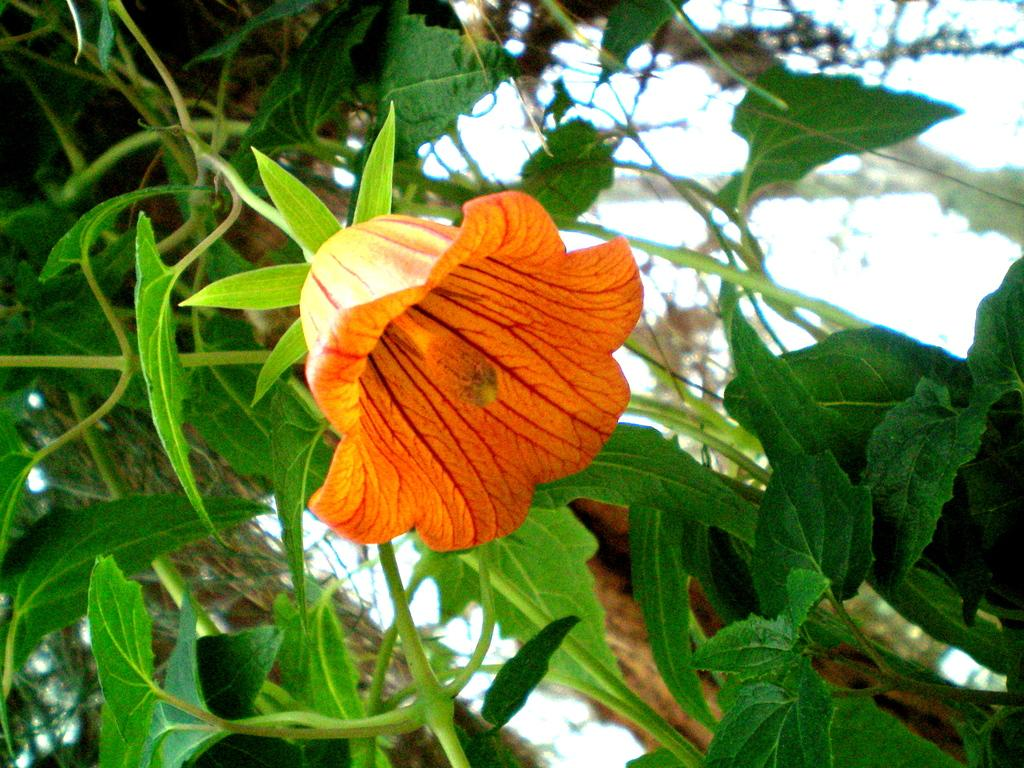What type of flower is in the image? There is an orange flower in the image. What color are the leaves in the background of the image? The leaves in the background of the image are green. What can be seen above the flower and leaves in the image? The sky is visible in the image. What type of desk can be seen in the image? There is no desk present in the image; it features an orange flower and green leaves in the background. 